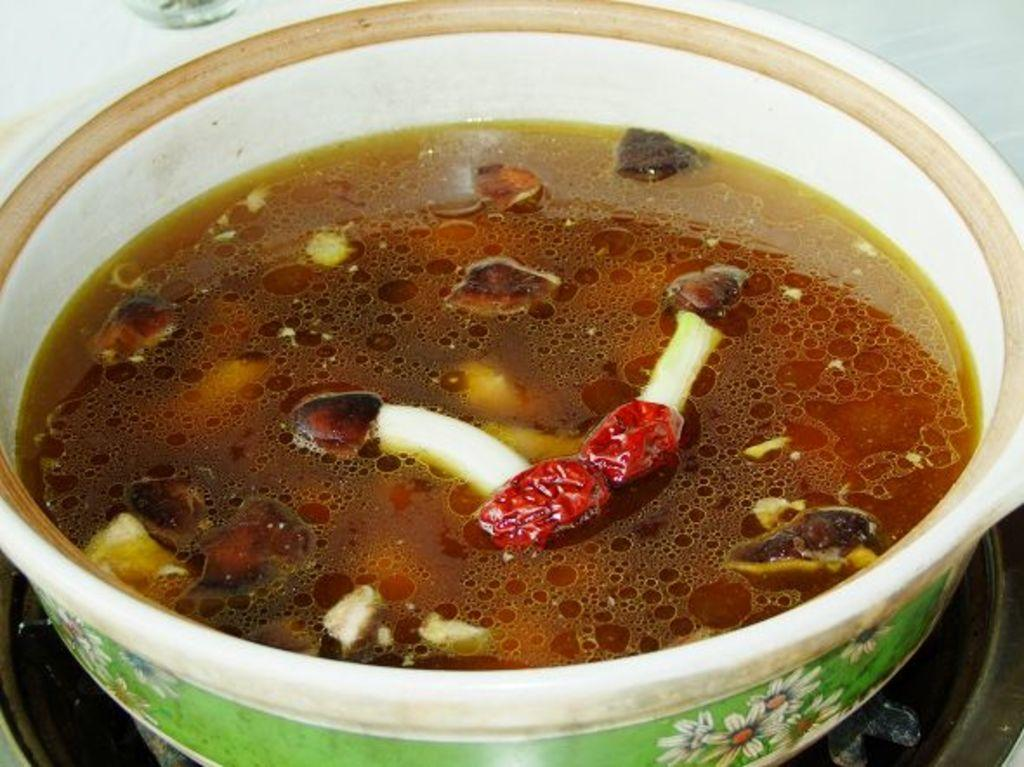What is in the bowl that is visible in the image? There is a bowl of soup in the image. What appliance is present in the image? There is a stove in the image. Who is the friend that is fighting with the sheet in the image? There is no friend or sheet present in the image; it only features a bowl of soup and a stove. 